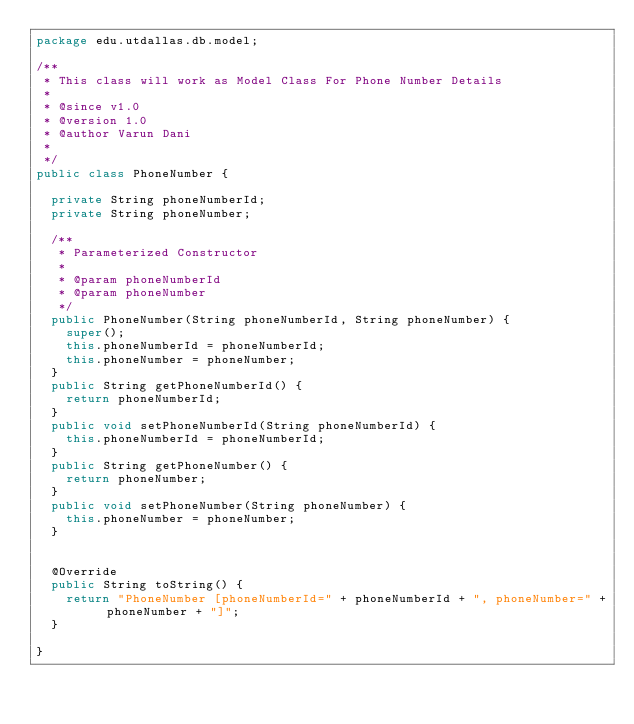Convert code to text. <code><loc_0><loc_0><loc_500><loc_500><_Java_>package edu.utdallas.db.model;

/**
 * This class will work as Model Class For Phone Number Details
 * 
 * @since v1.0
 * @version 1.0
 * @author Varun Dani
 *
 */
public class PhoneNumber {

	private String phoneNumberId;
	private String phoneNumber;
	
	/**
	 * Parameterized Constructor 
	 * 
	 * @param phoneNumberId
	 * @param phoneNumber
	 */
	public PhoneNumber(String phoneNumberId, String phoneNumber) {
		super();
		this.phoneNumberId = phoneNumberId;
		this.phoneNumber = phoneNumber;
	}
	public String getPhoneNumberId() {
		return phoneNumberId;
	}
	public void setPhoneNumberId(String phoneNumberId) {
		this.phoneNumberId = phoneNumberId;
	}
	public String getPhoneNumber() {
		return phoneNumber;
	}
	public void setPhoneNumber(String phoneNumber) {
		this.phoneNumber = phoneNumber;
	}
	

	@Override
	public String toString() {
		return "PhoneNumber [phoneNumberId=" + phoneNumberId + ", phoneNumber=" + phoneNumber + "]";
	}
	
}
</code> 